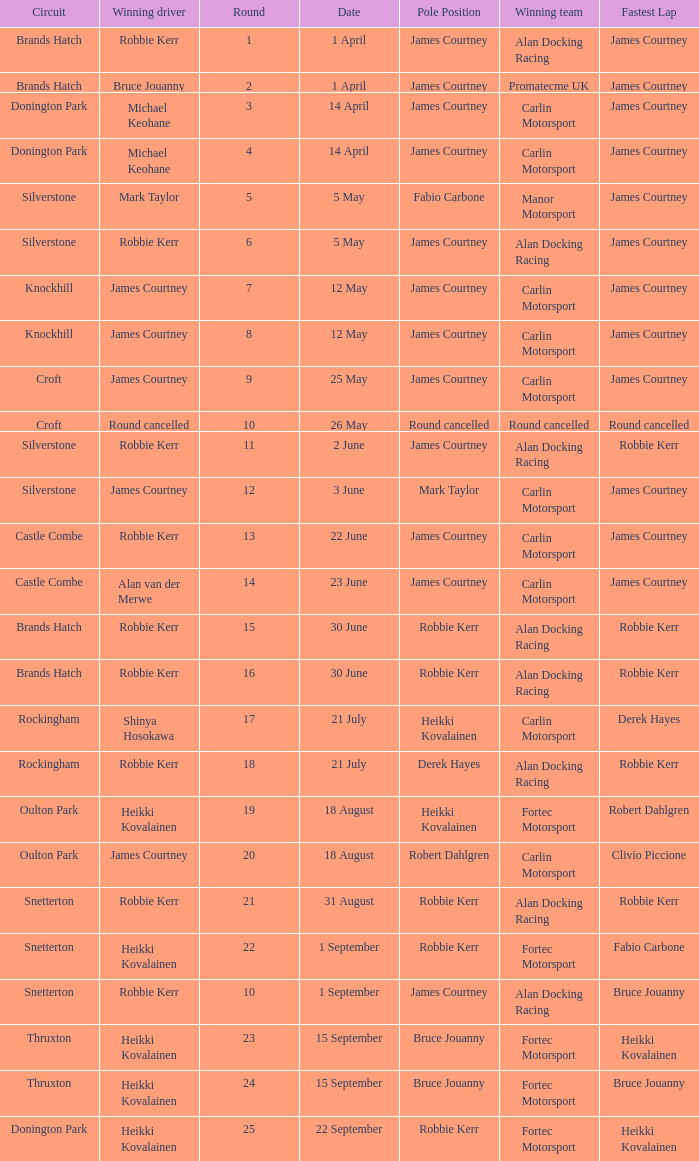How many rounds have Fabio Carbone for fastest lap? 1.0. 